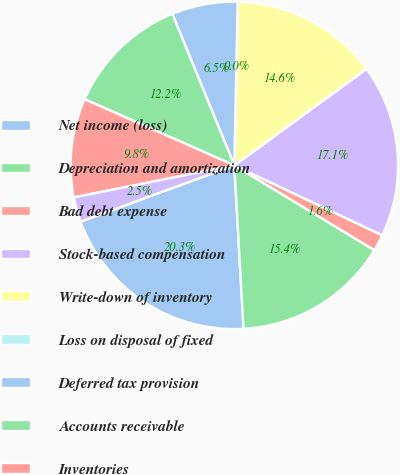Convert chart. <chart><loc_0><loc_0><loc_500><loc_500><pie_chart><fcel>Net income (loss)<fcel>Depreciation and amortization<fcel>Bad debt expense<fcel>Stock-based compensation<fcel>Write-down of inventory<fcel>Loss on disposal of fixed<fcel>Deferred tax provision<fcel>Accounts receivable<fcel>Inventories<fcel>Prepaid expenses and other<nl><fcel>20.3%<fcel>15.44%<fcel>1.64%<fcel>17.06%<fcel>14.62%<fcel>0.02%<fcel>6.51%<fcel>12.19%<fcel>9.76%<fcel>2.45%<nl></chart> 